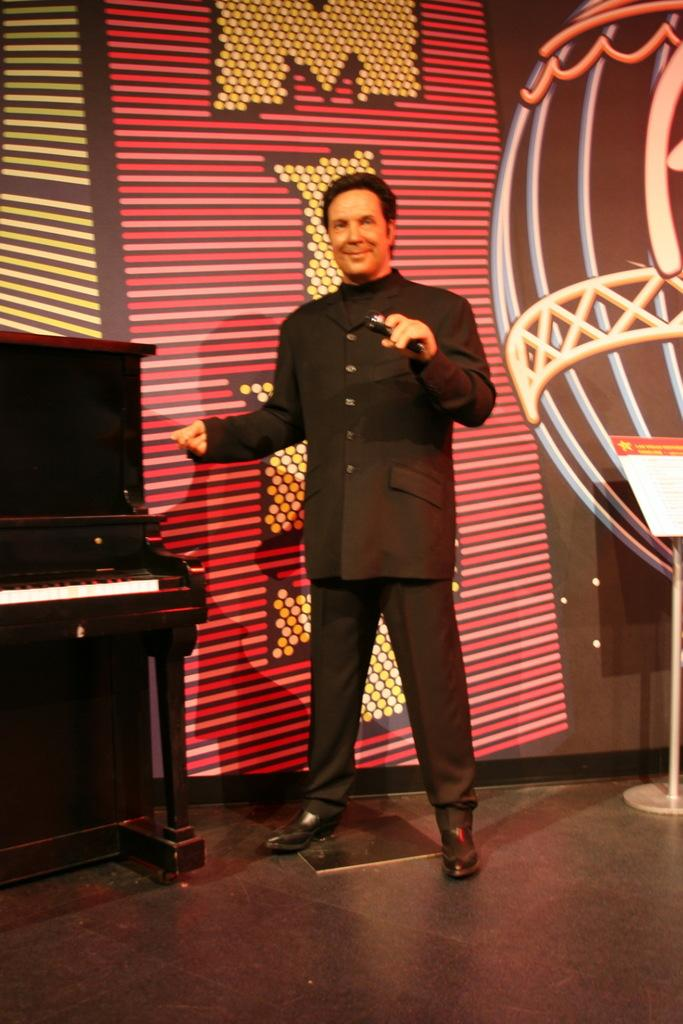What is the main subject of the image? There is a man standing in the image. Where is the man standing? The man is standing on the floor. What other objects can be seen in the image? There is a table in the image. What is visible in the background of the image? There is a wall visible in the background of the image. What channel is the man watching on the table in the image? There is no television or channel visible in the image; it only shows a man standing on the floor and a table. How many legs does the man have in the image? The man has two legs, which is typical for humans. 